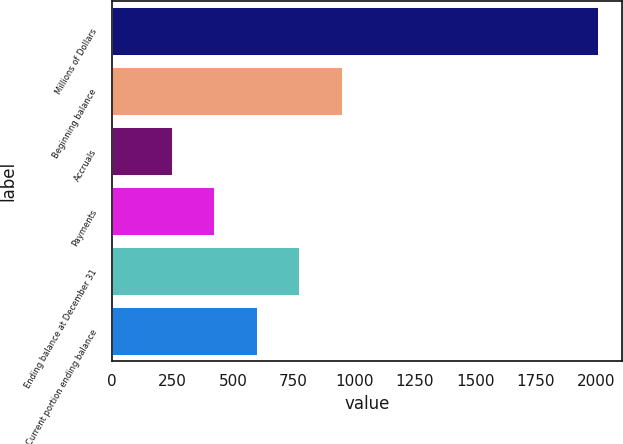Convert chart to OTSL. <chart><loc_0><loc_0><loc_500><loc_500><bar_chart><fcel>Millions of Dollars<fcel>Beginning balance<fcel>Accruals<fcel>Payments<fcel>Ending balance at December 31<fcel>Current portion ending balance<nl><fcel>2005<fcel>950.2<fcel>247<fcel>422.8<fcel>774.4<fcel>598.6<nl></chart> 